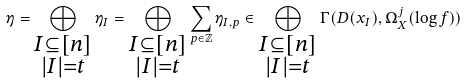<formula> <loc_0><loc_0><loc_500><loc_500>\eta = \bigoplus _ { \substack { I \subseteq [ n ] \\ | I | = t } } \eta _ { I } = \bigoplus _ { \substack { I \subseteq [ n ] \\ | I | = t } } \sum _ { p \in \mathbb { Z } } \eta _ { I , p } \in \bigoplus _ { \substack { I \subseteq [ n ] \\ | I | = t } } \Gamma ( D ( x _ { I } ) , \Omega _ { X } ^ { j } ( \log f ) )</formula> 